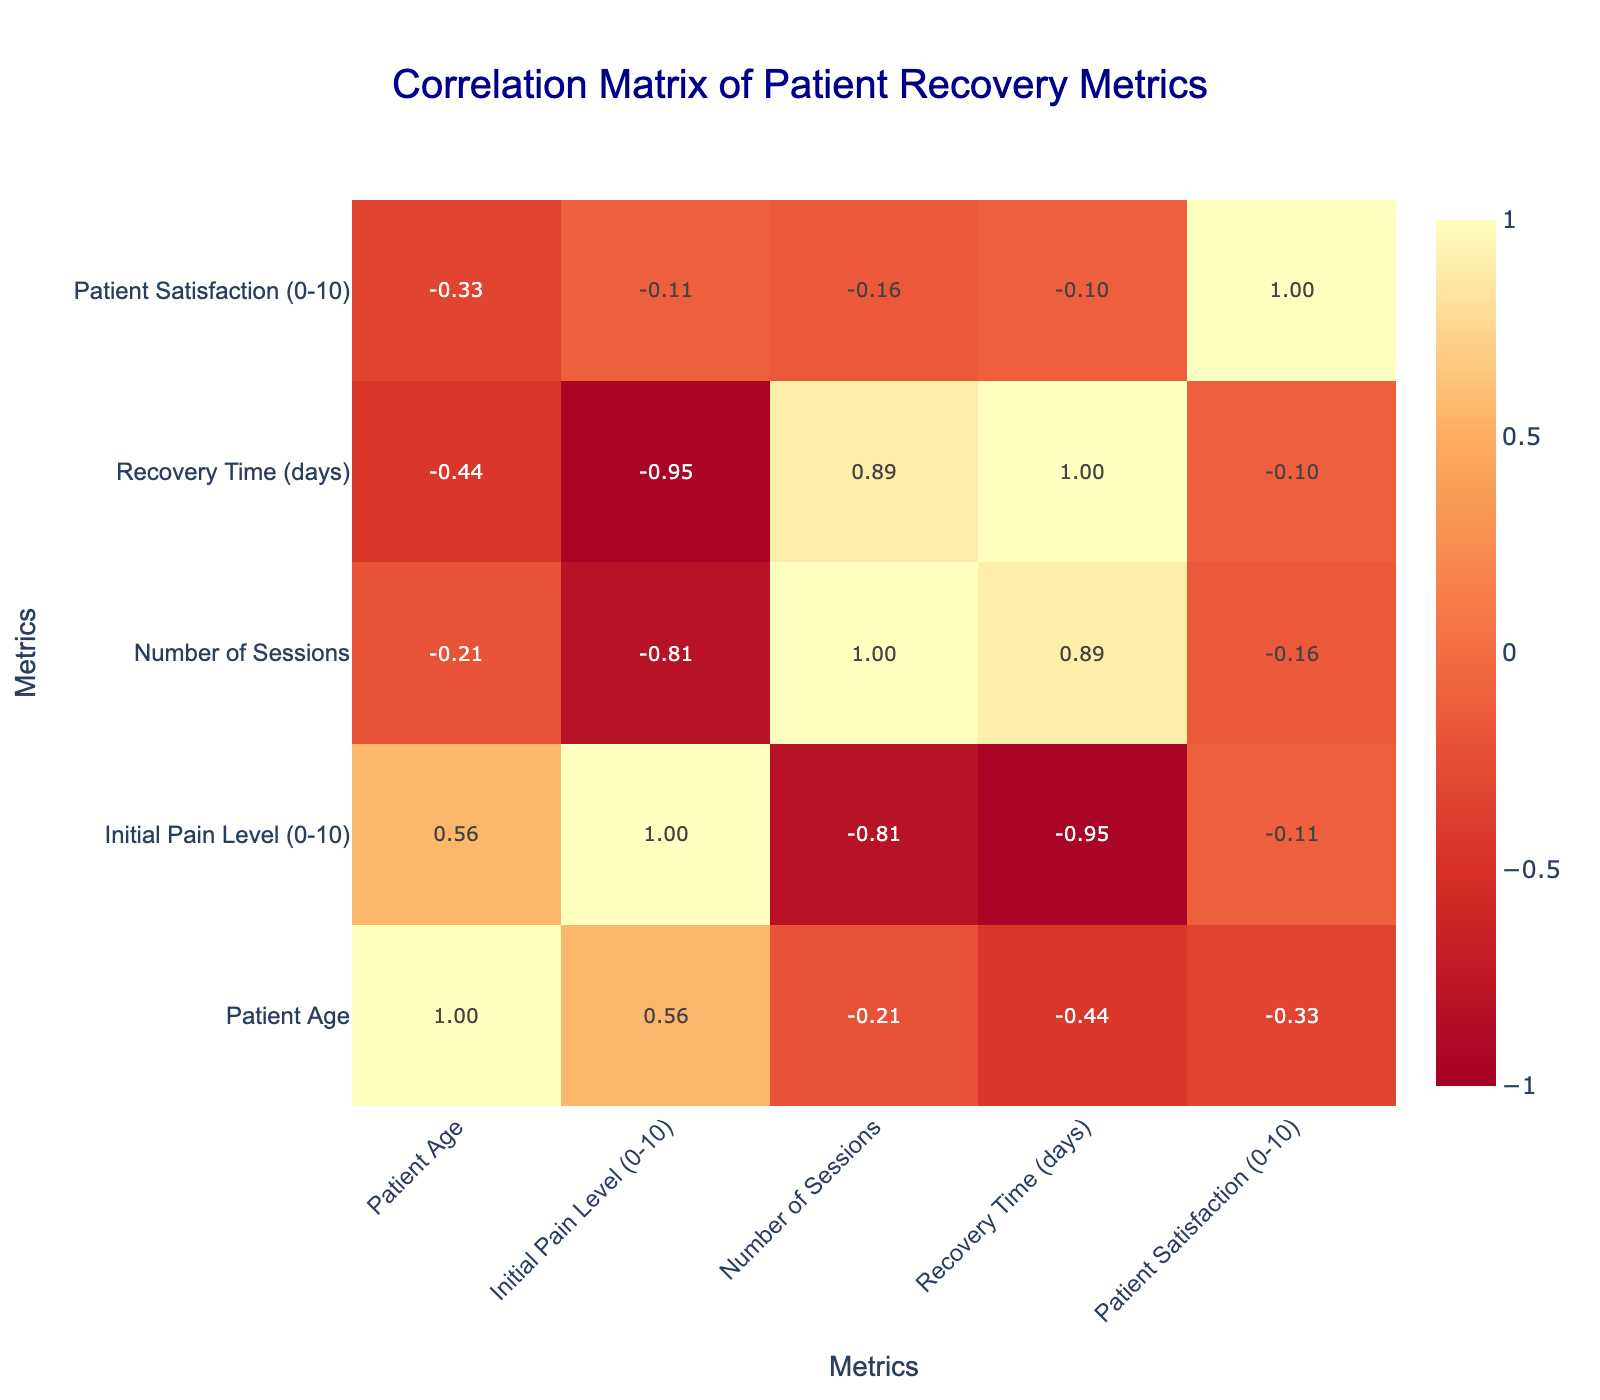What is the correlation between the Initial Pain Level and Patient Satisfaction? Referring to the correlation matrix, we look for the value at the intersection of 'Initial Pain Level' row and 'Patient Satisfaction' column. It shows a negative correlation of -0.74, indicating that as the initial pain level increases, patient satisfaction tends to decrease.
Answer: -0.74 Which treatment method has the highest correlation with Patient Satisfaction? By inspecting the correlation matrix, we check the correlations of all treatment methods with 'Patient Satisfaction'. The highest correlation value is 0.73 for Combination Therapy, suggesting that this method is associated with greater patient satisfaction.
Answer: Combination Therapy What is the average Recovery Time for patients who underwent Manual Therapy and Hydrotherapy? We identify the Recovery Time for both treatments: Manual Therapy has a recovery time of 30 days and Hydrotherapy has 35 days. Summing these values gives 65, and dividing by 2 results in an average of 32.5 days.
Answer: 32.5 days Is there a positive correlation between the Number of Sessions and Recovery Time? The correlation matrix shows a correlation value of 0.11 between 'Number of Sessions' and 'Recovery Time', indicating a negligible positive correlation; thus, we can conclude that there is not a significant positive relationship.
Answer: No What is the difference in average Initial Pain Level between patients who received Exercise Therapy and those who received Acupuncture? The Initial Pain Level for Exercise Therapy is 6 and for Acupuncture it is 9. The average for Exercise Therapy is 6, and for Acupuncture is 9. The difference between these two averages is 9 - 6 = 3.
Answer: 3 What is the correlation between Patient Age and Recovery Time? In the correlation matrix, the value at the intersection of 'Patient Age' and 'Recovery Time' is -0.46, indicating a moderate negative correlation; as patient age increases, recovery time tends to decrease.
Answer: -0.46 Is Acupuncture associated with lower Initial Pain Levels than Electrotherapy? The Initial Pain Level for Acupuncture is 9, while for Electrotherapy, it is 5. Therefore, Acupuncture is associated with a higher Initial Pain Level than Electrotherapy.
Answer: No What is the total Patient Satisfaction score for all treatments combined, and how does it average per treatment method? Adding up the Patient Satisfaction scores gives us a total of 49 (8 + 9 + 7 + 6 + 8 + 9 + 8 + 7 + 7 + 9 = 49) across 10 treatments. Dividing 49 by 10 gives an average score of 4.9.
Answer: 4.9 